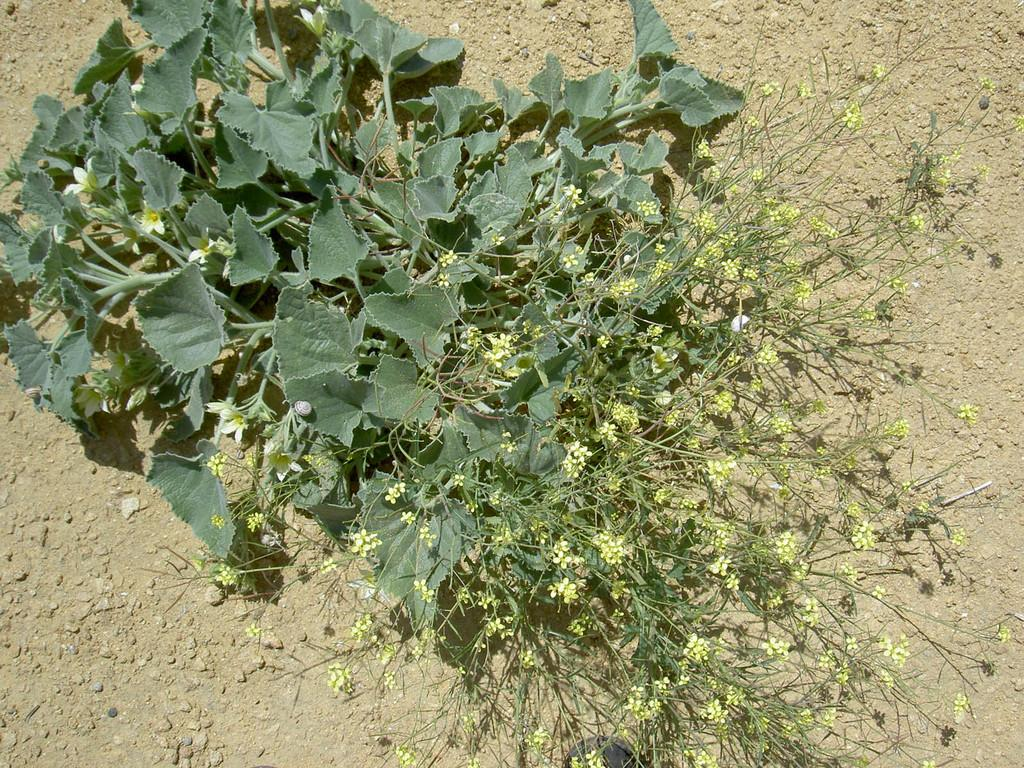What is present in the image? There is a plant in the image. Where is the plant located? The plant is on the soil. What type of drug can be seen in the image? There is no drug present in the image; it is a plant on the soil. What button is being pressed by the plant in the image? There is no button present in the image, as it features a plant on the soil. 